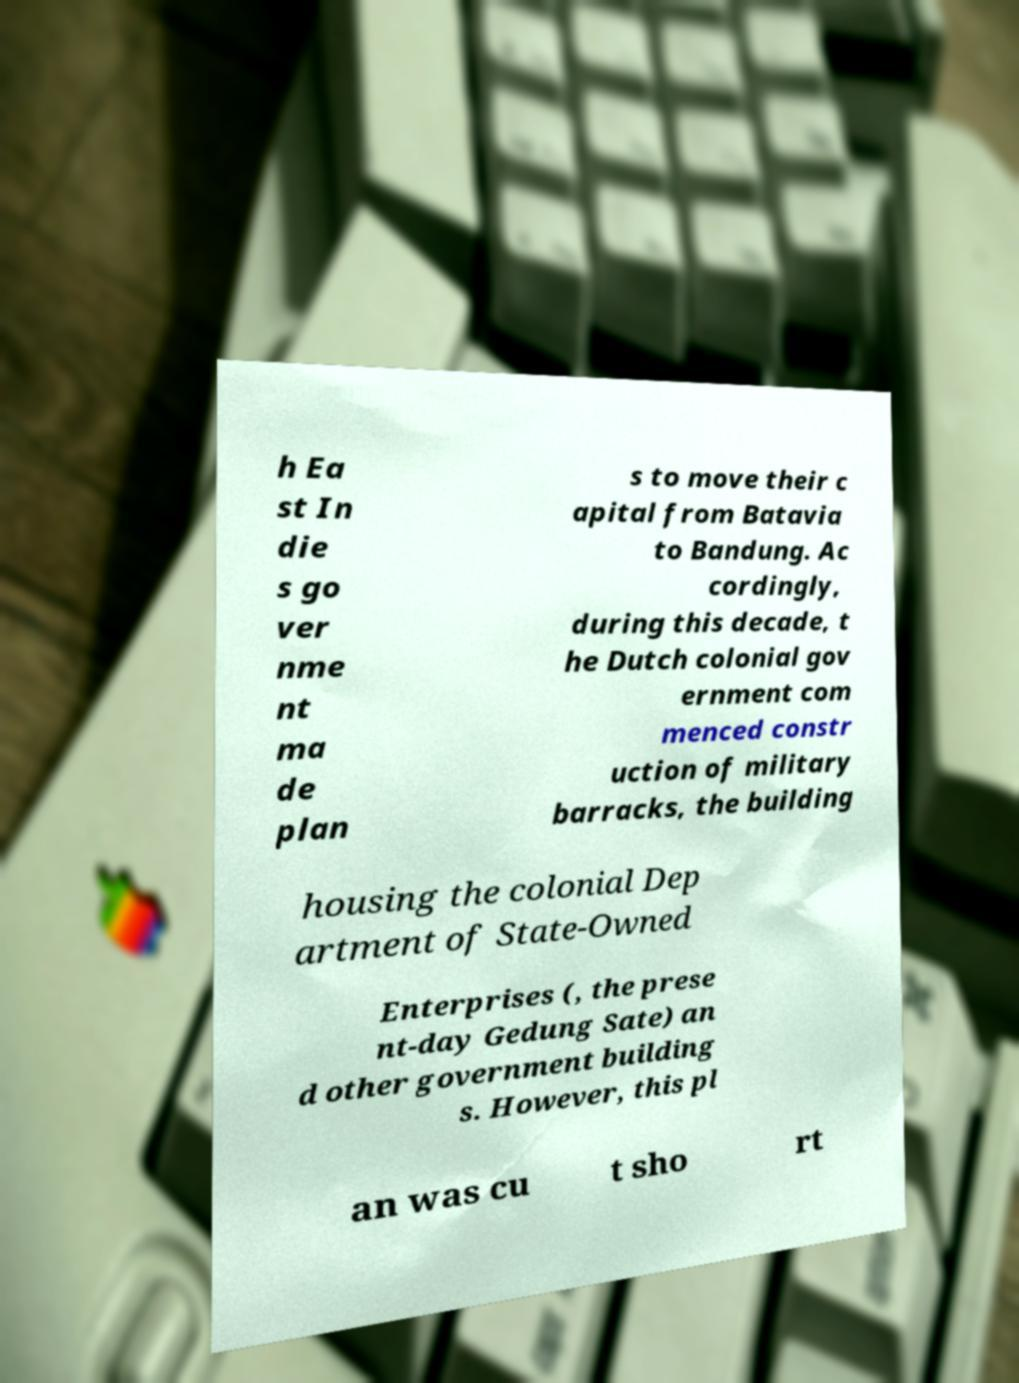Can you accurately transcribe the text from the provided image for me? h Ea st In die s go ver nme nt ma de plan s to move their c apital from Batavia to Bandung. Ac cordingly, during this decade, t he Dutch colonial gov ernment com menced constr uction of military barracks, the building housing the colonial Dep artment of State-Owned Enterprises (, the prese nt-day Gedung Sate) an d other government building s. However, this pl an was cu t sho rt 